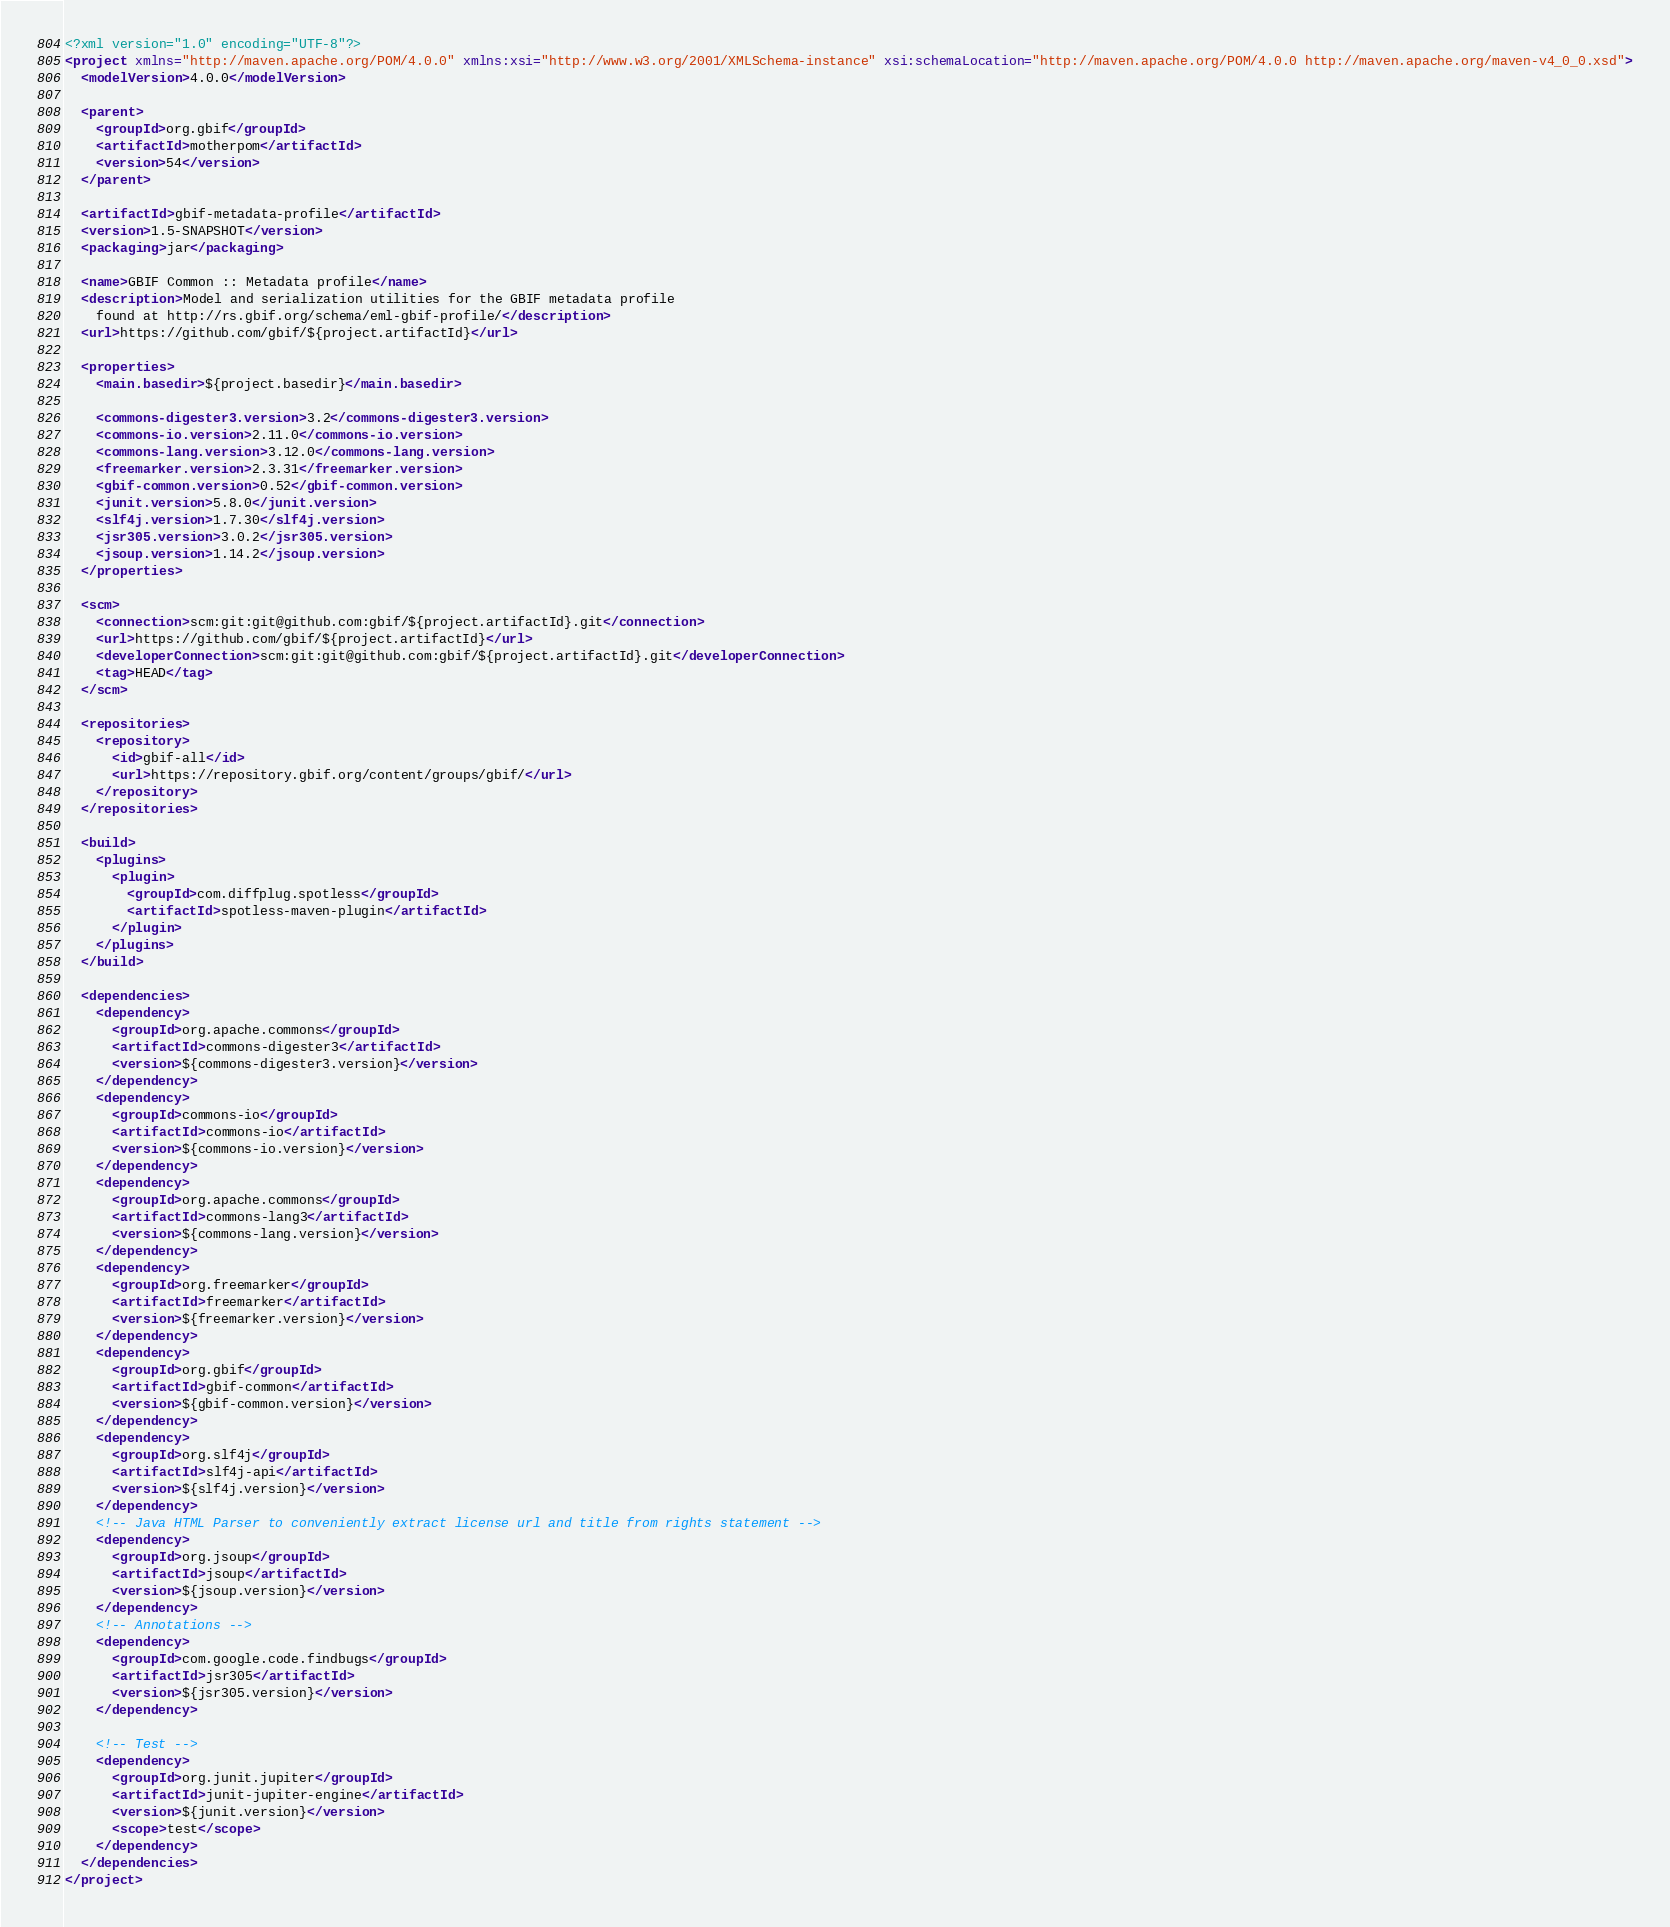<code> <loc_0><loc_0><loc_500><loc_500><_XML_><?xml version="1.0" encoding="UTF-8"?>
<project xmlns="http://maven.apache.org/POM/4.0.0" xmlns:xsi="http://www.w3.org/2001/XMLSchema-instance" xsi:schemaLocation="http://maven.apache.org/POM/4.0.0 http://maven.apache.org/maven-v4_0_0.xsd">
  <modelVersion>4.0.0</modelVersion>

  <parent>
    <groupId>org.gbif</groupId>
    <artifactId>motherpom</artifactId>
    <version>54</version>
  </parent>

  <artifactId>gbif-metadata-profile</artifactId>
  <version>1.5-SNAPSHOT</version>
  <packaging>jar</packaging>

  <name>GBIF Common :: Metadata profile</name>
  <description>Model and serialization utilities for the GBIF metadata profile
    found at http://rs.gbif.org/schema/eml-gbif-profile/</description>
  <url>https://github.com/gbif/${project.artifactId}</url>

  <properties>
    <main.basedir>${project.basedir}</main.basedir>

    <commons-digester3.version>3.2</commons-digester3.version>
    <commons-io.version>2.11.0</commons-io.version>
    <commons-lang.version>3.12.0</commons-lang.version>
    <freemarker.version>2.3.31</freemarker.version>
    <gbif-common.version>0.52</gbif-common.version>
    <junit.version>5.8.0</junit.version>
    <slf4j.version>1.7.30</slf4j.version>
    <jsr305.version>3.0.2</jsr305.version>
    <jsoup.version>1.14.2</jsoup.version>
  </properties>

  <scm>
    <connection>scm:git:git@github.com:gbif/${project.artifactId}.git</connection>
    <url>https://github.com/gbif/${project.artifactId}</url>
    <developerConnection>scm:git:git@github.com:gbif/${project.artifactId}.git</developerConnection>
    <tag>HEAD</tag>
  </scm>

  <repositories>
    <repository>
      <id>gbif-all</id>
      <url>https://repository.gbif.org/content/groups/gbif/</url>
    </repository>
  </repositories>

  <build>
    <plugins>
      <plugin>
        <groupId>com.diffplug.spotless</groupId>
        <artifactId>spotless-maven-plugin</artifactId>
      </plugin>
    </plugins>
  </build>

  <dependencies>
    <dependency>
      <groupId>org.apache.commons</groupId>
      <artifactId>commons-digester3</artifactId>
      <version>${commons-digester3.version}</version>
    </dependency>
    <dependency>
      <groupId>commons-io</groupId>
      <artifactId>commons-io</artifactId>
      <version>${commons-io.version}</version>
    </dependency>
    <dependency>
      <groupId>org.apache.commons</groupId>
      <artifactId>commons-lang3</artifactId>
      <version>${commons-lang.version}</version>
    </dependency>
    <dependency>
      <groupId>org.freemarker</groupId>
      <artifactId>freemarker</artifactId>
      <version>${freemarker.version}</version>
    </dependency>
    <dependency>
      <groupId>org.gbif</groupId>
      <artifactId>gbif-common</artifactId>
      <version>${gbif-common.version}</version>
    </dependency>
    <dependency>
      <groupId>org.slf4j</groupId>
      <artifactId>slf4j-api</artifactId>
      <version>${slf4j.version}</version>
    </dependency>
    <!-- Java HTML Parser to conveniently extract license url and title from rights statement -->
    <dependency>
      <groupId>org.jsoup</groupId>
      <artifactId>jsoup</artifactId>
      <version>${jsoup.version}</version>
    </dependency>
    <!-- Annotations -->
    <dependency>
      <groupId>com.google.code.findbugs</groupId>
      <artifactId>jsr305</artifactId>
      <version>${jsr305.version}</version>
    </dependency>

    <!-- Test -->
    <dependency>
      <groupId>org.junit.jupiter</groupId>
      <artifactId>junit-jupiter-engine</artifactId>
      <version>${junit.version}</version>
      <scope>test</scope>
    </dependency>
  </dependencies>
</project>
</code> 